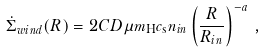<formula> <loc_0><loc_0><loc_500><loc_500>\dot { \Sigma } _ { w i n d } ( R ) = 2 C D \mu m _ { \mathrm H } c _ { \mathrm s } n _ { i n } \left ( \frac { R } { R _ { i n } } \right ) ^ { - a } \, ,</formula> 